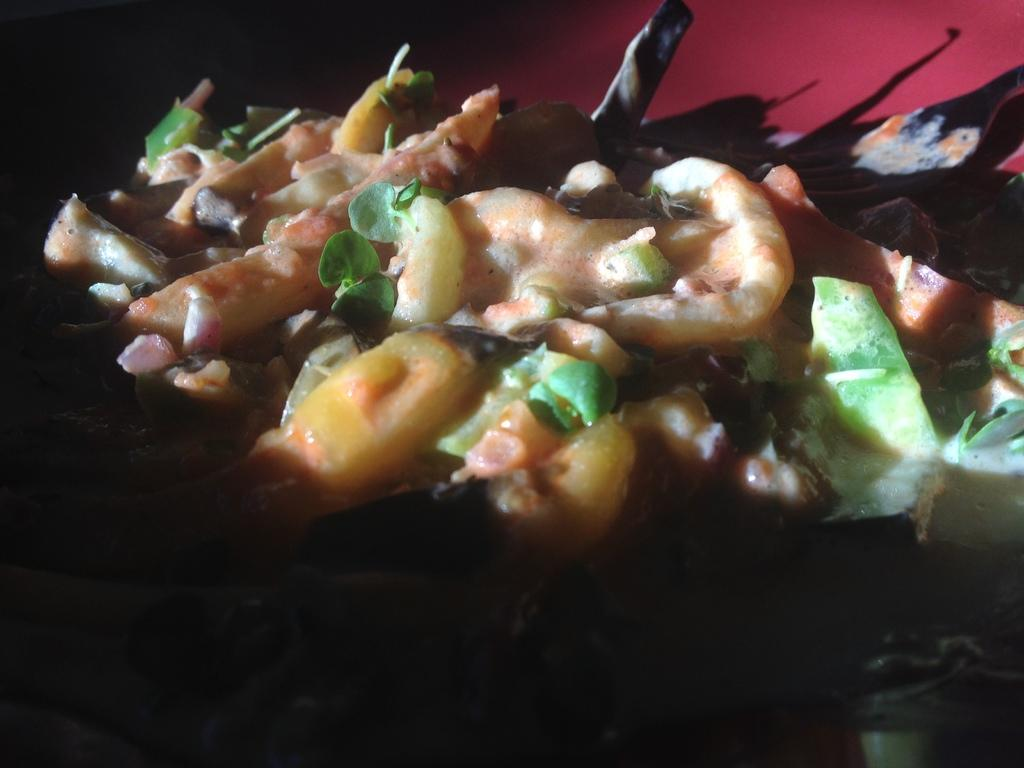What is the main subject of the image? There is a food item in the image. How is the food item presented in the image? The food item is in a plate. How many boys are standing near the mailbox in the image? There are no boys or mailboxes present in the image; it only features a food item in a plate. 